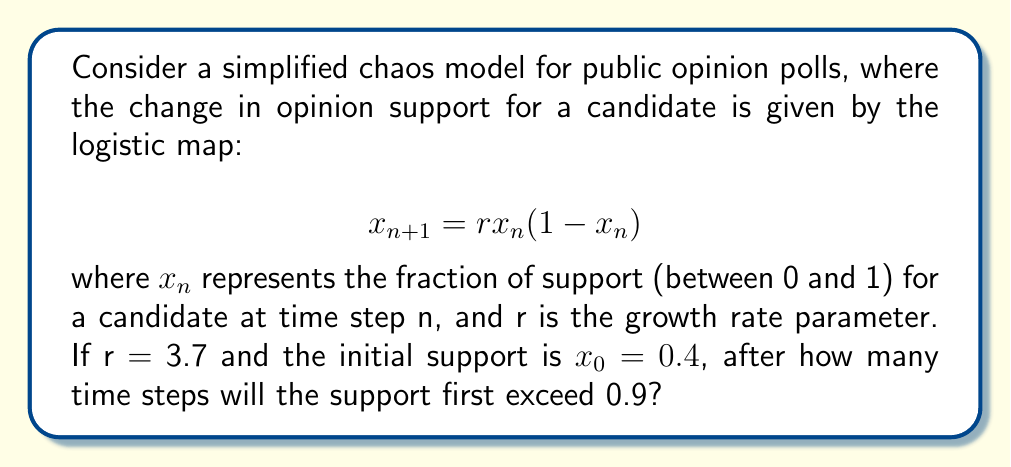What is the answer to this math problem? To solve this problem, we need to iterate the logistic map equation until we find a value that exceeds 0.9. Let's go through this step-by-step:

1) We start with $r = 3.7$ and $x_0 = 0.4$

2) For $n = 1$:
   $x_1 = 3.7 * 0.4 * (1-0.4) = 0.888$

3) For $n = 2$:
   $x_2 = 3.7 * 0.888 * (1-0.888) = 0.3681216$

4) For $n = 3$:
   $x_3 = 3.7 * 0.3681216 * (1-0.3681216) = 0.8614954$

5) For $n = 4$:
   $x_4 = 3.7 * 0.8614954 * (1-0.8614954) = 0.4419373$

6) For $n = 5$:
   $x_5 = 3.7 * 0.4419373 * (1-0.4419373) = 0.9129399$

At $n = 5$, we see that the support exceeds 0.9 for the first time.

This demonstrates how chaos theory can be applied to understand fluctuations in public opinion polls. Even with a simple deterministic model, we observe complex behavior that can be difficult to predict long-term, mimicking the unpredictable nature of real-world public opinion.
Answer: 5 time steps 